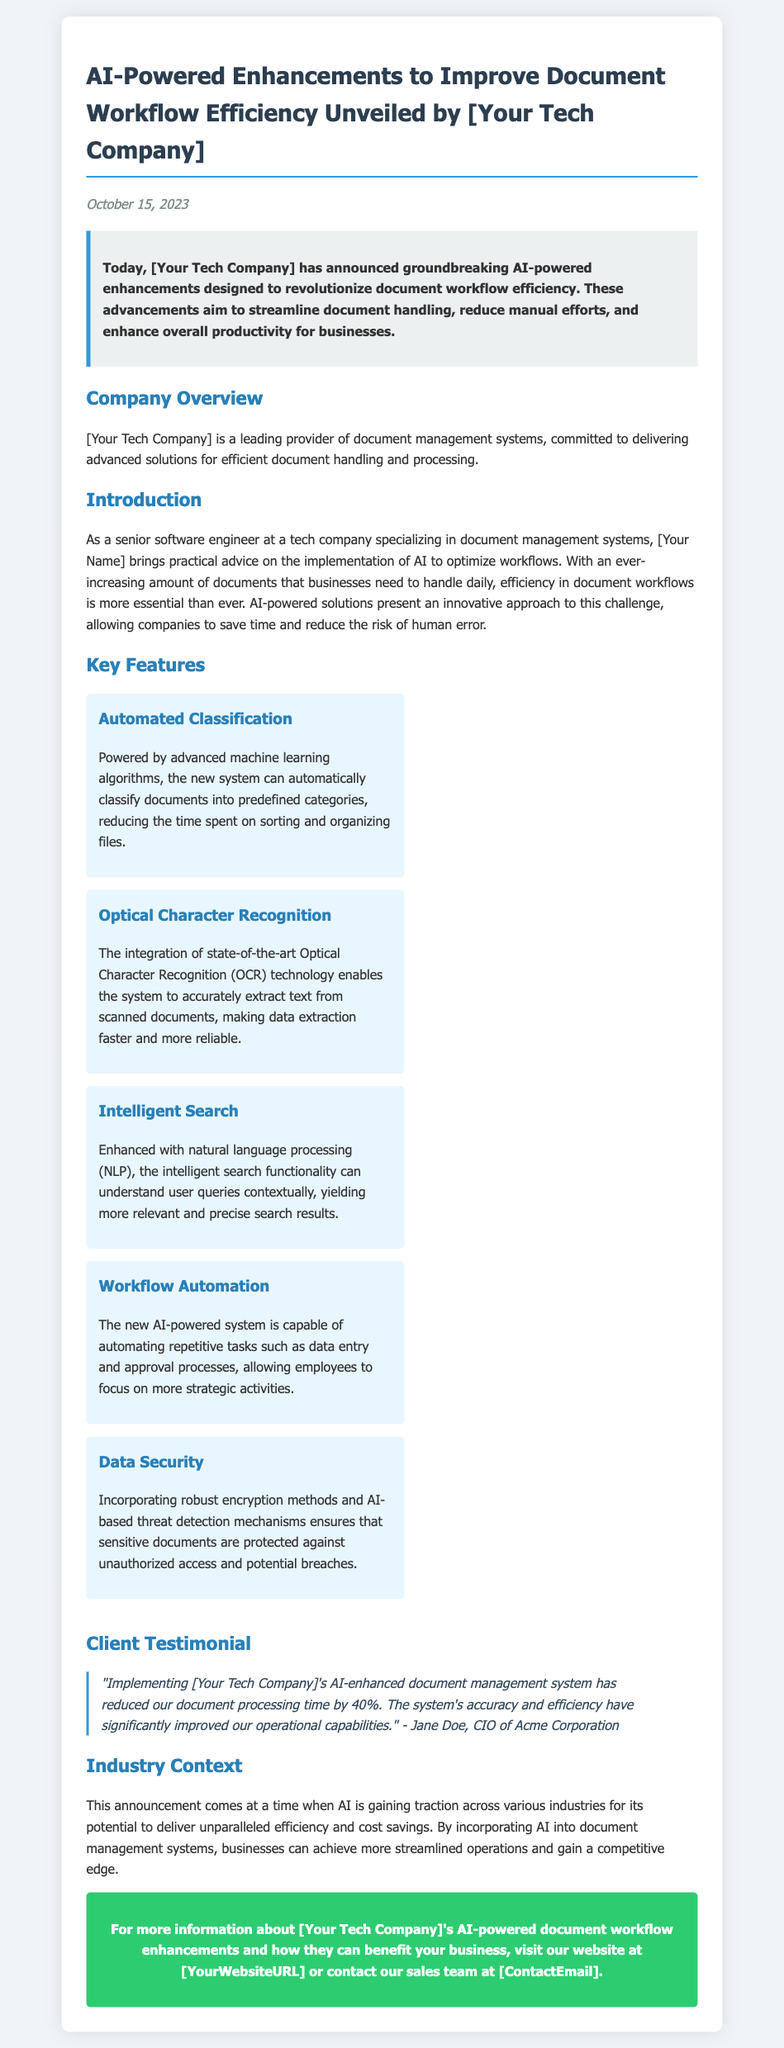What are the new features announced? The document lists several key features aimed at enhancing document workflow, such as automated classification and intelligent search.
Answer: Automated classification, Optical Character Recognition, Intelligent Search, Workflow Automation, Data Security Who is the CIO of Acme Corporation? The document includes a testimonial that names Jane Doe as the CIO of Acme Corporation.
Answer: Jane Doe When was the press release announced? The date of announcement is mentioned in the document as October 15, 2023.
Answer: October 15, 2023 What company unveiled the AI-powered enhancements? The document refers to the company as [Your Tech Company], which is where the enhancements originated.
Answer: [Your Tech Company] What percentage reduction in document processing time did Acme Corporation experience? The testimonial in the document states a specific reduction percentage of document processing time due to the new system.
Answer: 40% What technology is used for data extraction in the new system? The document specifies the use of Optical Character Recognition technology for accurate text extraction from scanned documents.
Answer: Optical Character Recognition What aspect of the system helps to automate repetitive tasks? The document mentions a feature that allows automation of tasks such as data entry and approval processes.
Answer: Workflow Automation What is the main goal of the AI enhancements according to the press release? The document outlines that the enhancements are aimed at streamlining document handling and reducing manual efforts.
Answer: Improve document workflow efficiency What does the background color of the summary section indicate? The summary section features a distinct background color to highlight its importance and separate it from other text.
Answer: Highlighted information 